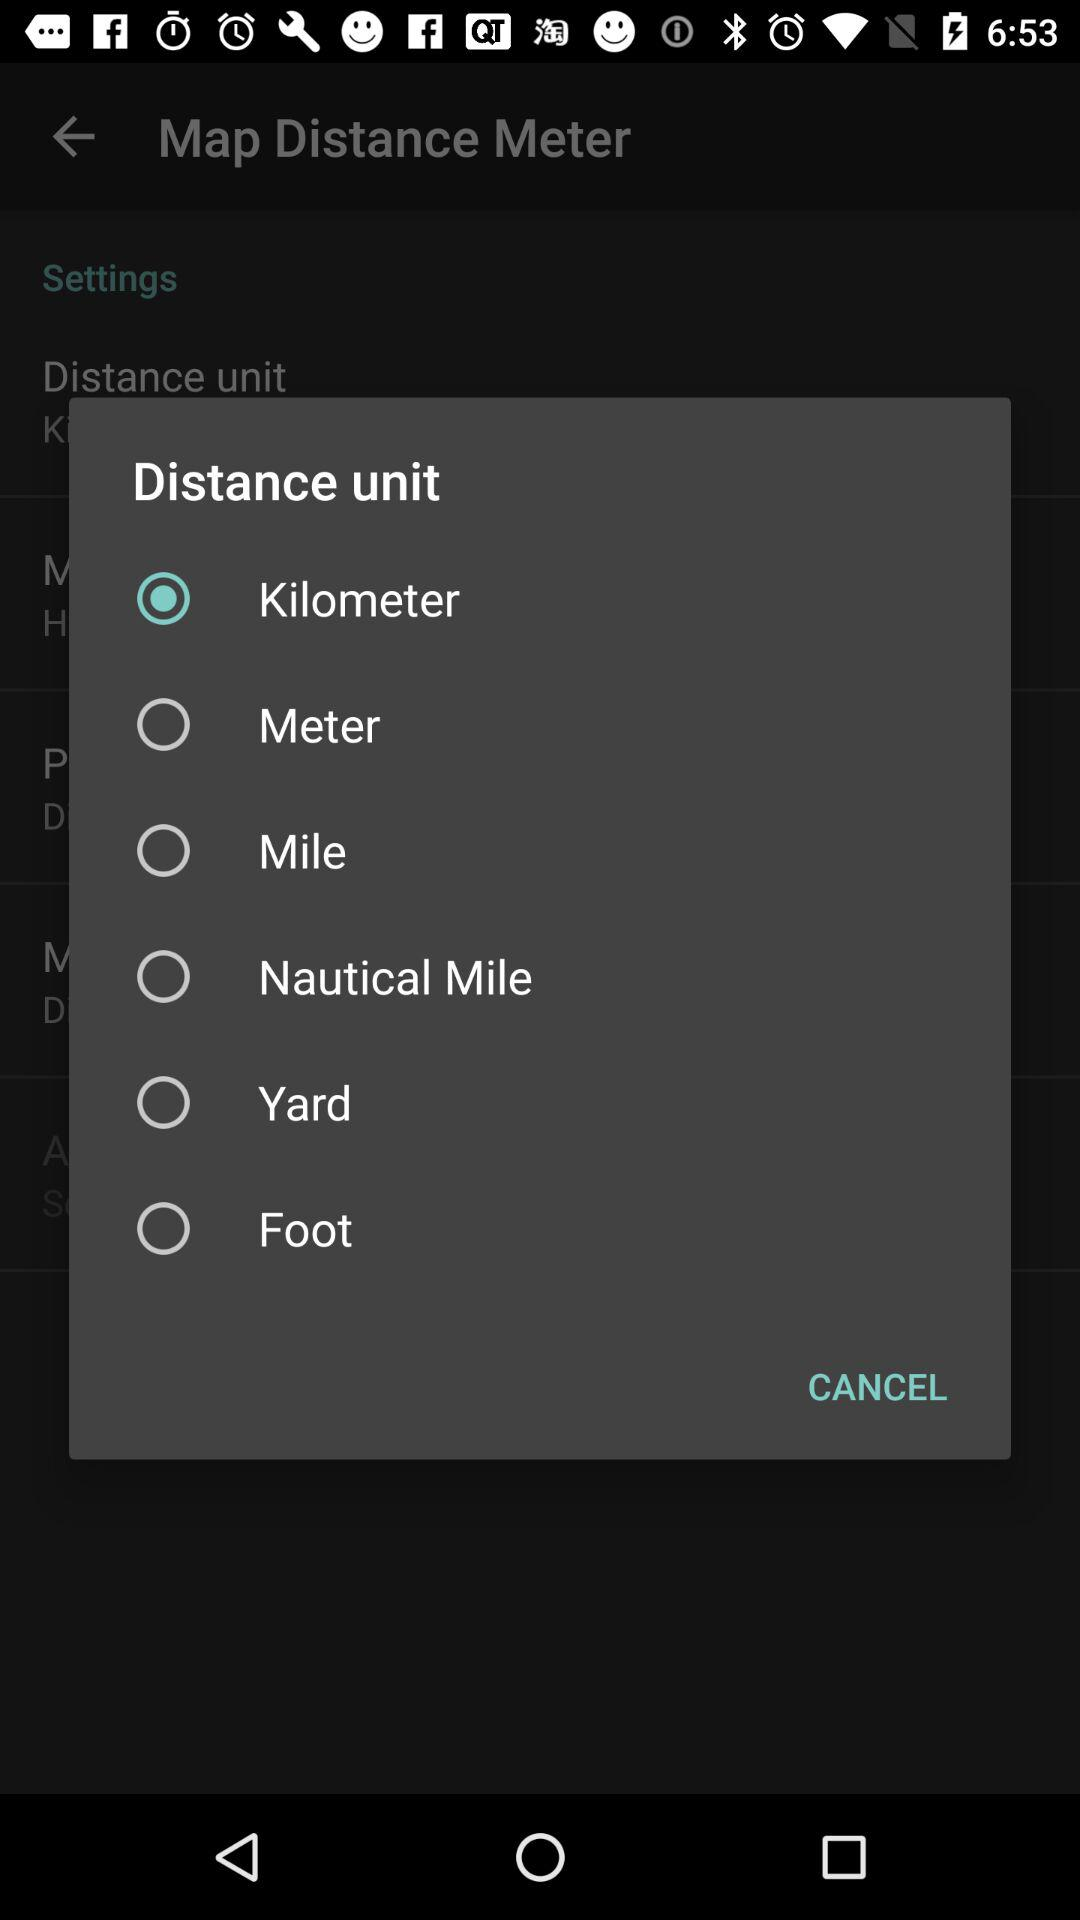Which distance unit is selected? The selected distance unit is "Kilometer". 